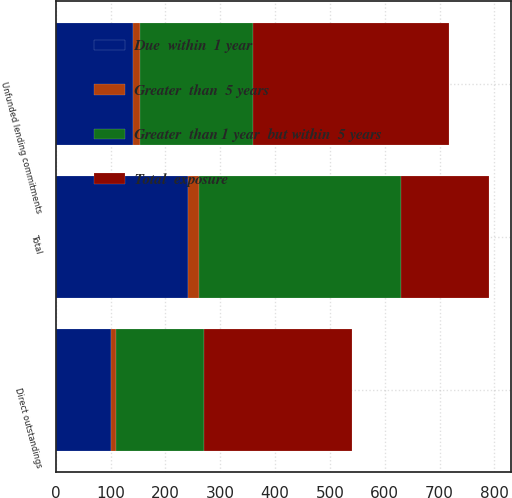<chart> <loc_0><loc_0><loc_500><loc_500><stacked_bar_chart><ecel><fcel>Direct outstandings<fcel>Unfunded lending commitments<fcel>Total<nl><fcel>Greater  than 1 year  but within  5 years<fcel>161<fcel>206<fcel>367<nl><fcel>Due  within  1 year<fcel>100<fcel>141<fcel>241<nl><fcel>Greater  than  5 years<fcel>9<fcel>12<fcel>21<nl><fcel>Total  exposure<fcel>270<fcel>359<fcel>161<nl></chart> 